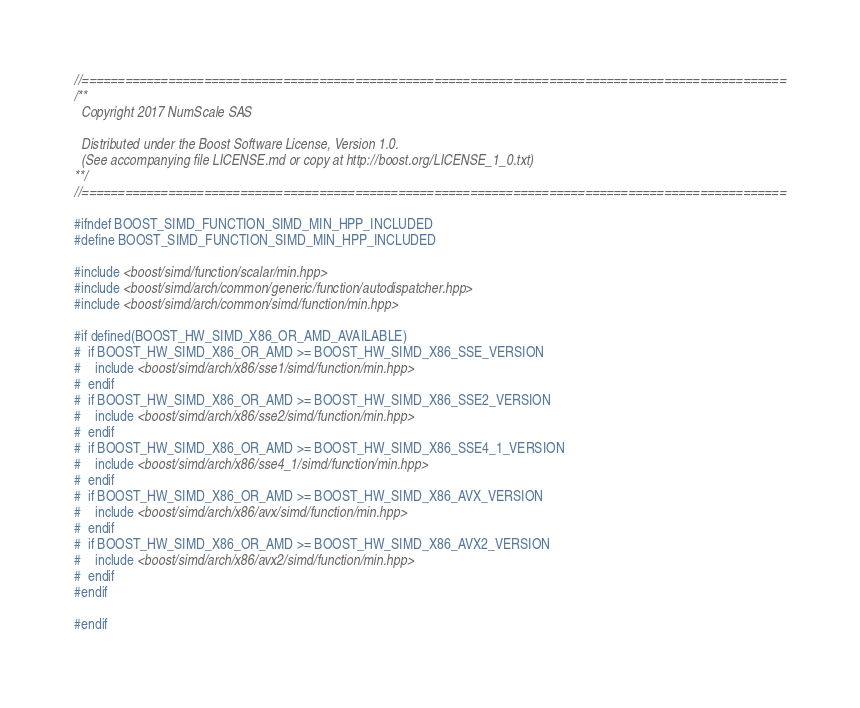Convert code to text. <code><loc_0><loc_0><loc_500><loc_500><_C++_>//==================================================================================================
/**
  Copyright 2017 NumScale SAS

  Distributed under the Boost Software License, Version 1.0.
  (See accompanying file LICENSE.md or copy at http://boost.org/LICENSE_1_0.txt)
**/
//==================================================================================================

#ifndef BOOST_SIMD_FUNCTION_SIMD_MIN_HPP_INCLUDED
#define BOOST_SIMD_FUNCTION_SIMD_MIN_HPP_INCLUDED

#include <boost/simd/function/scalar/min.hpp>
#include <boost/simd/arch/common/generic/function/autodispatcher.hpp>
#include <boost/simd/arch/common/simd/function/min.hpp>

#if defined(BOOST_HW_SIMD_X86_OR_AMD_AVAILABLE)
#  if BOOST_HW_SIMD_X86_OR_AMD >= BOOST_HW_SIMD_X86_SSE_VERSION
#    include <boost/simd/arch/x86/sse1/simd/function/min.hpp>
#  endif
#  if BOOST_HW_SIMD_X86_OR_AMD >= BOOST_HW_SIMD_X86_SSE2_VERSION
#    include <boost/simd/arch/x86/sse2/simd/function/min.hpp>
#  endif
#  if BOOST_HW_SIMD_X86_OR_AMD >= BOOST_HW_SIMD_X86_SSE4_1_VERSION
#    include <boost/simd/arch/x86/sse4_1/simd/function/min.hpp>
#  endif
#  if BOOST_HW_SIMD_X86_OR_AMD >= BOOST_HW_SIMD_X86_AVX_VERSION
#    include <boost/simd/arch/x86/avx/simd/function/min.hpp>
#  endif
#  if BOOST_HW_SIMD_X86_OR_AMD >= BOOST_HW_SIMD_X86_AVX2_VERSION
#    include <boost/simd/arch/x86/avx2/simd/function/min.hpp>
#  endif
#endif

#endif
</code> 